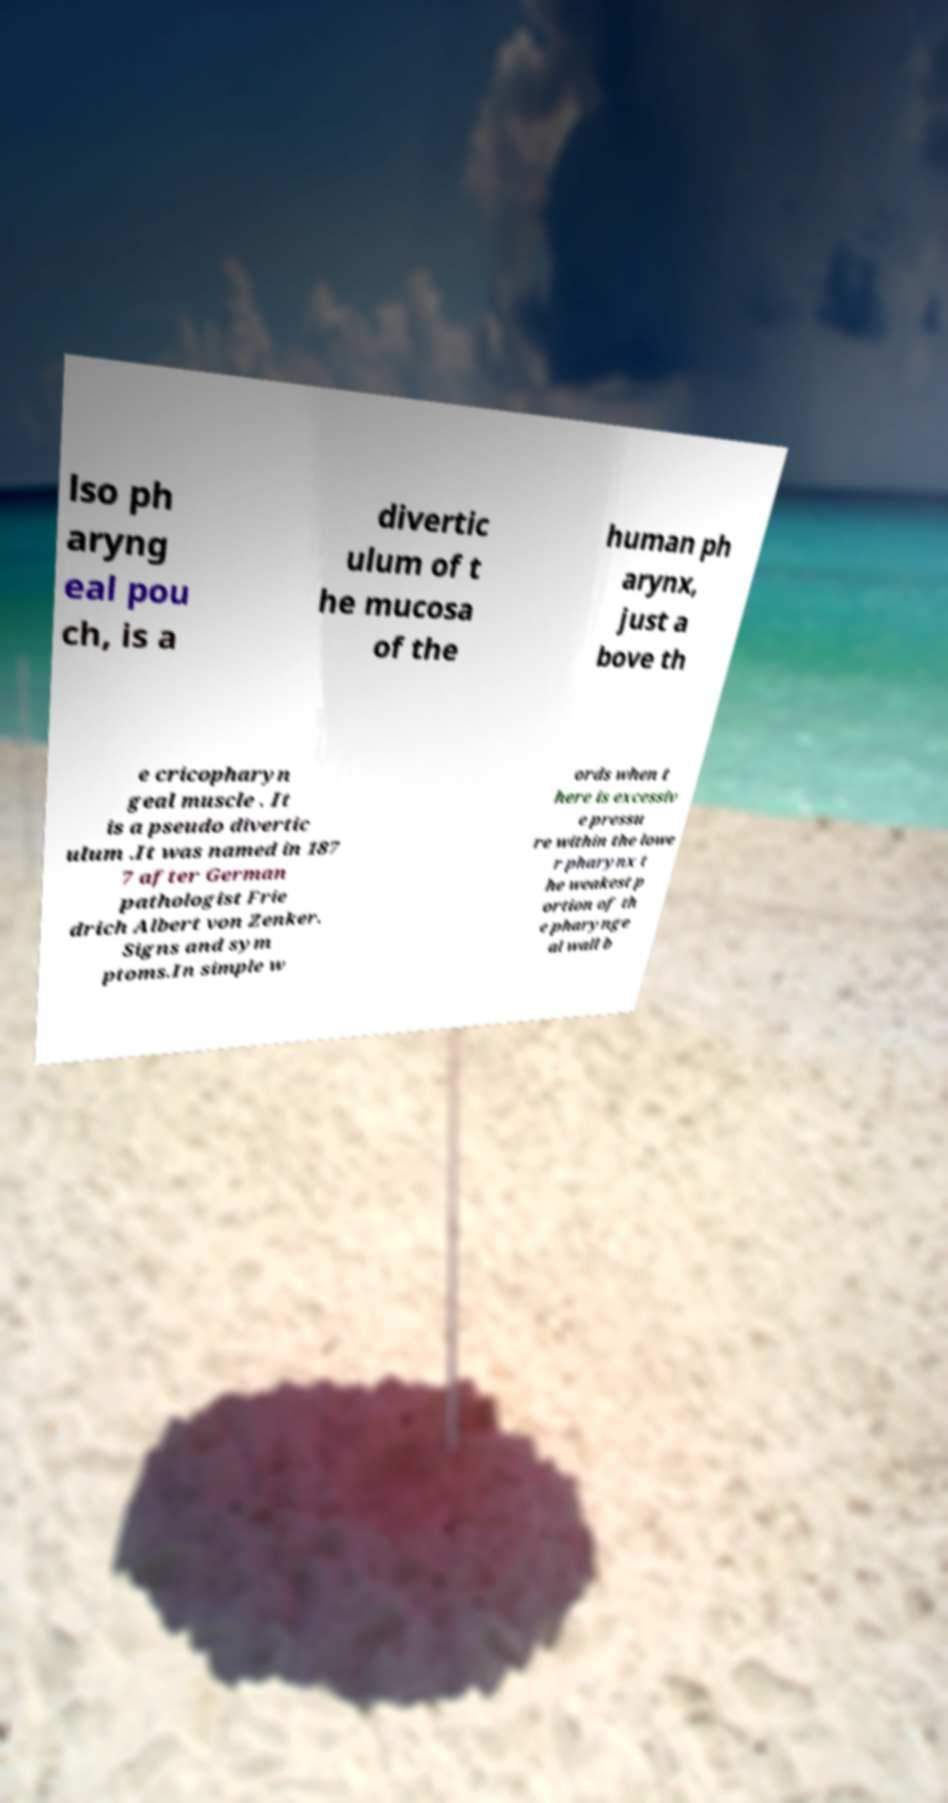Please identify and transcribe the text found in this image. lso ph aryng eal pou ch, is a divertic ulum of t he mucosa of the human ph arynx, just a bove th e cricopharyn geal muscle . It is a pseudo divertic ulum .It was named in 187 7 after German pathologist Frie drich Albert von Zenker. Signs and sym ptoms.In simple w ords when t here is excessiv e pressu re within the lowe r pharynx t he weakest p ortion of th e pharynge al wall b 